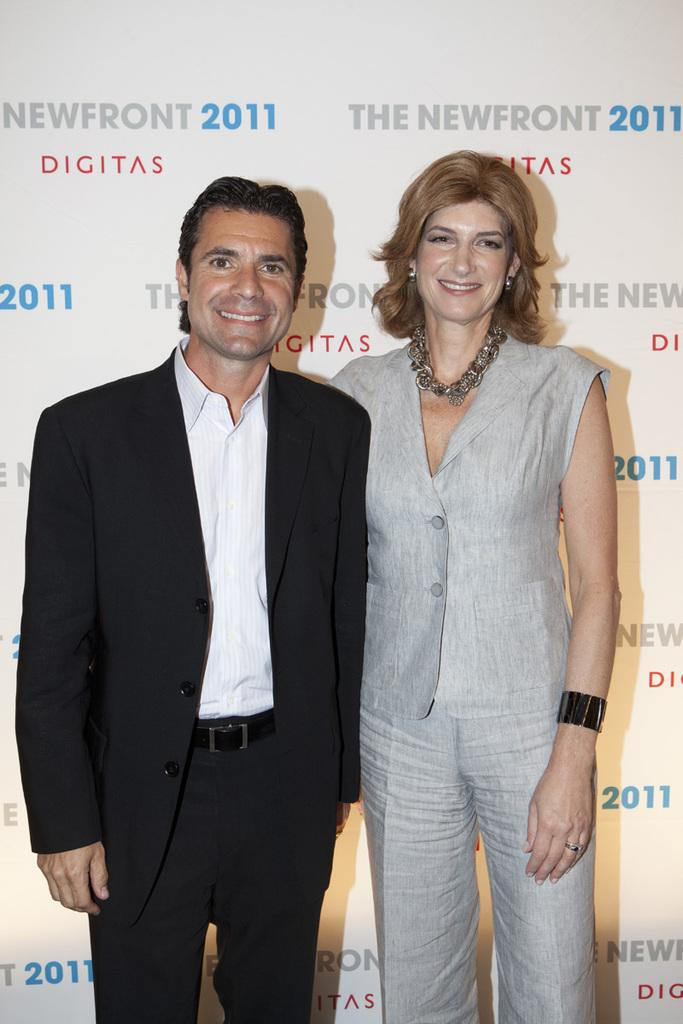What is the person wearing in the image? The person is wearing a suit in the image. Who is the person standing beside in the image? The person is standing beside a woman in the image. What can be seen behind the two individuals in the image? There is a banner with text behind them in the image. What type of drum is the fireman playing in the image? There is no drum or fireman present in the image. What type of store can be seen in the background of the image? There is no store visible in the image; it only features a person, a woman, and a banner with text. 